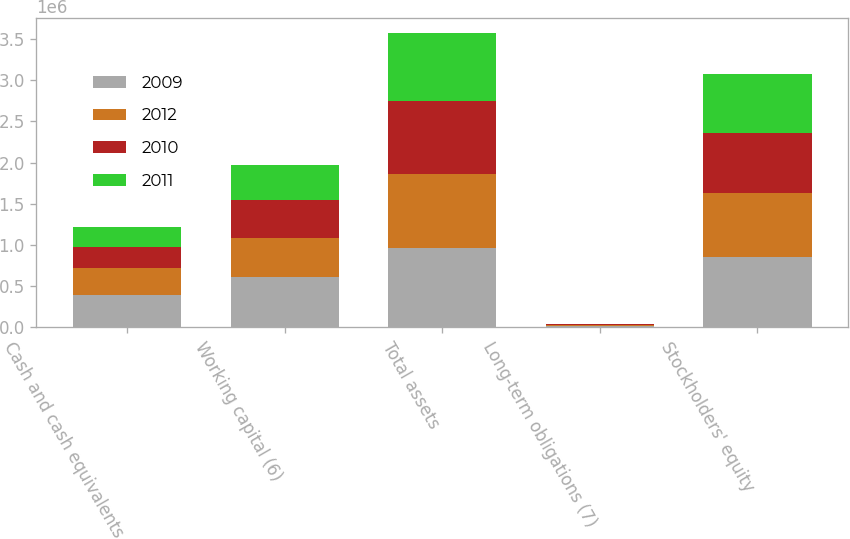Convert chart to OTSL. <chart><loc_0><loc_0><loc_500><loc_500><stacked_bar_chart><ecel><fcel>Cash and cash equivalents<fcel>Working capital (6)<fcel>Total assets<fcel>Long-term obligations (7)<fcel>Stockholders' equity<nl><fcel>2009<fcel>394075<fcel>615649<fcel>967748<fcel>14229<fcel>857002<nl><fcel>2012<fcel>326695<fcel>475899<fcel>899006<fcel>11515<fcel>776925<nl><fcel>2010<fcel>258598<fcel>455143<fcel>878864<fcel>10191<fcel>730032<nl><fcel>2011<fcel>245027<fcel>429277<fcel>830479<fcel>9012<fcel>712129<nl></chart> 